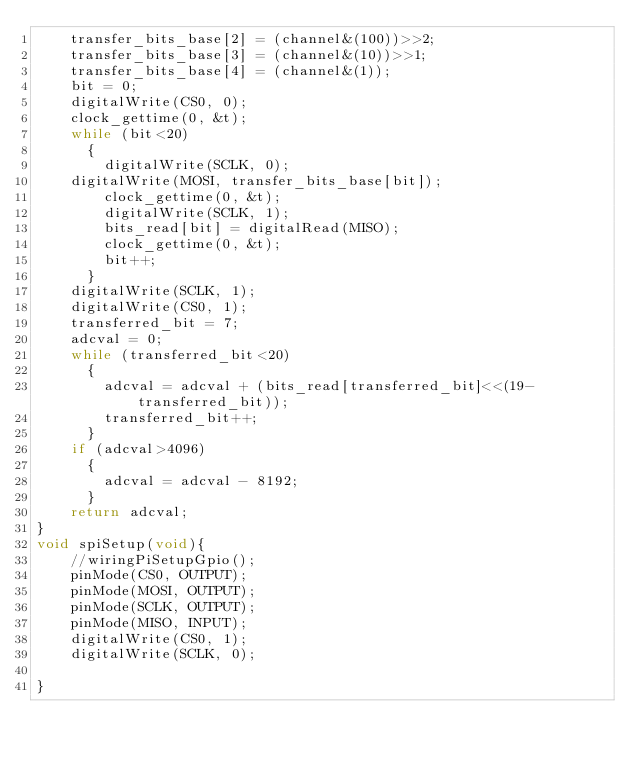Convert code to text. <code><loc_0><loc_0><loc_500><loc_500><_C_>    transfer_bits_base[2] = (channel&(100))>>2;
    transfer_bits_base[3] = (channel&(10))>>1;
    transfer_bits_base[4] = (channel&(1));
    bit = 0;
    digitalWrite(CS0, 0);
    clock_gettime(0, &t);
    while (bit<20)
      {
        digitalWrite(SCLK, 0);
	digitalWrite(MOSI, transfer_bits_base[bit]);
        clock_gettime(0, &t);
        digitalWrite(SCLK, 1);
        bits_read[bit] = digitalRead(MISO);
        clock_gettime(0, &t);
        bit++;
      }
    digitalWrite(SCLK, 1);
    digitalWrite(CS0, 1);
    transferred_bit = 7;
    adcval = 0;
    while (transferred_bit<20)
      {
        adcval = adcval + (bits_read[transferred_bit]<<(19-transferred_bit));
        transferred_bit++;
      }
    if (adcval>4096)
      {
        adcval = adcval - 8192;
      }
    return adcval;
}
void spiSetup(void){
	//wiringPiSetupGpio();
    pinMode(CS0, OUTPUT);
    pinMode(MOSI, OUTPUT);
    pinMode(SCLK, OUTPUT);
    pinMode(MISO, INPUT);
    digitalWrite(CS0, 1);
    digitalWrite(SCLK, 0);

}
</code> 